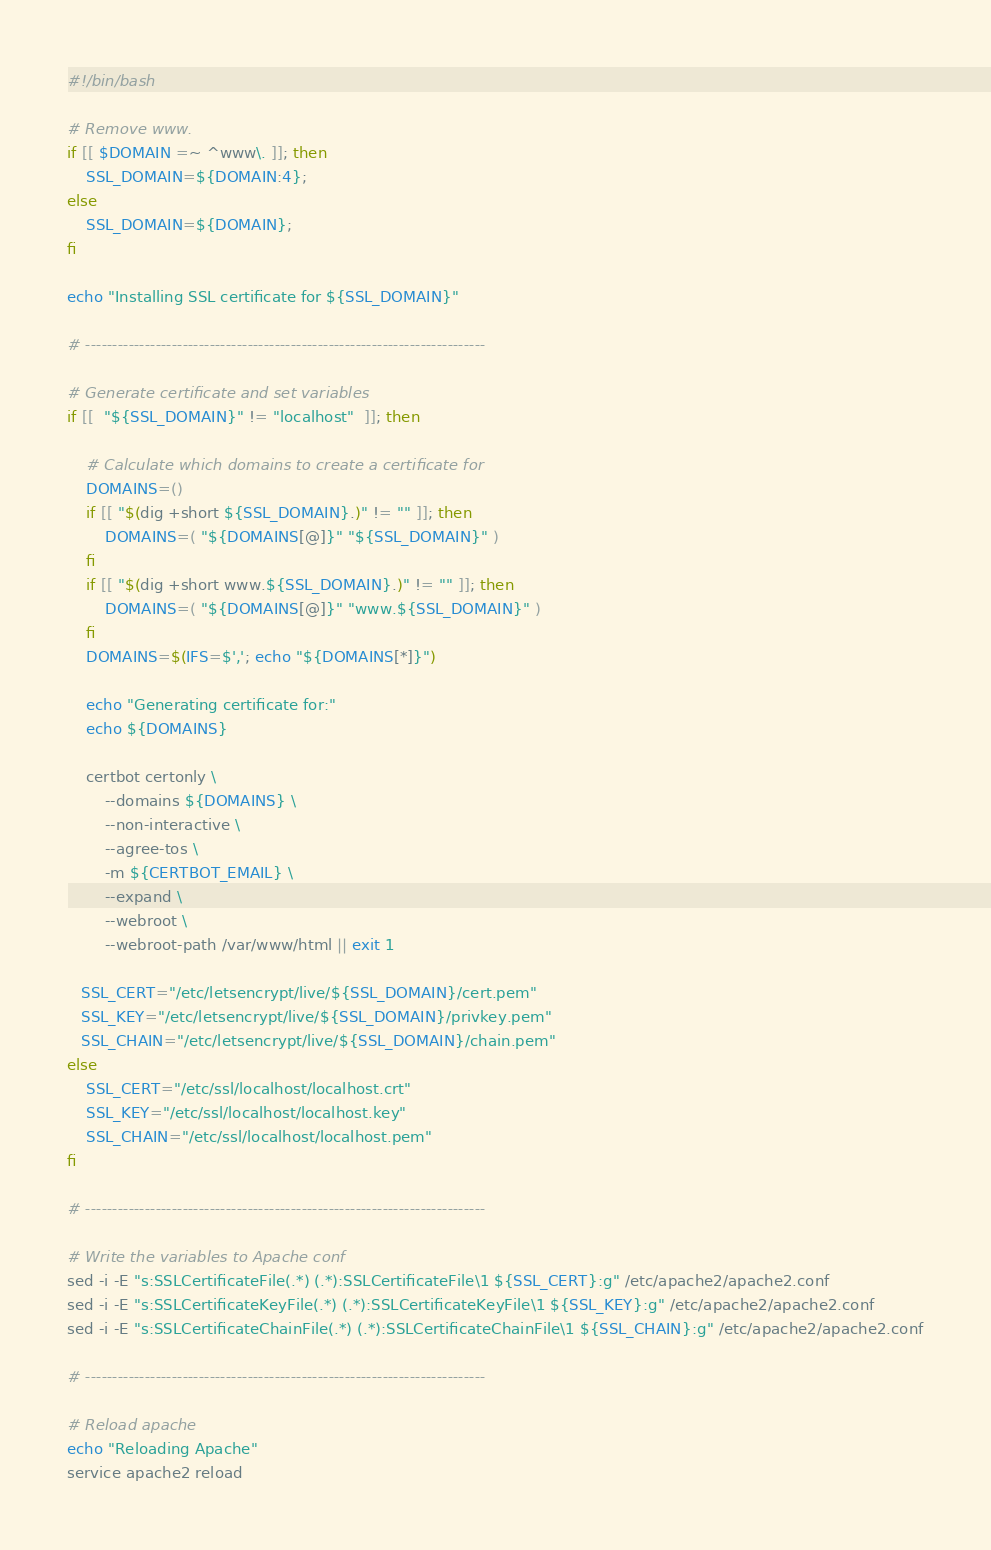Convert code to text. <code><loc_0><loc_0><loc_500><loc_500><_Bash_>#!/bin/bash

# Remove www.
if [[ $DOMAIN =~ ^www\. ]]; then
    SSL_DOMAIN=${DOMAIN:4};
else
    SSL_DOMAIN=${DOMAIN};
fi

echo "Installing SSL certificate for ${SSL_DOMAIN}"

# --------------------------------------------------------------------------

# Generate certificate and set variables
if [[  "${SSL_DOMAIN}" != "localhost"  ]]; then

    # Calculate which domains to create a certificate for
    DOMAINS=()
    if [[ "$(dig +short ${SSL_DOMAIN}.)" != "" ]]; then
        DOMAINS=( "${DOMAINS[@]}" "${SSL_DOMAIN}" )
    fi
    if [[ "$(dig +short www.${SSL_DOMAIN}.)" != "" ]]; then
        DOMAINS=( "${DOMAINS[@]}" "www.${SSL_DOMAIN}" )
    fi
    DOMAINS=$(IFS=$','; echo "${DOMAINS[*]}")

    echo "Generating certificate for:"
    echo ${DOMAINS}

    certbot certonly \
        --domains ${DOMAINS} \
        --non-interactive \
        --agree-tos \
        -m ${CERTBOT_EMAIL} \
        --expand \
        --webroot \
        --webroot-path /var/www/html || exit 1

   SSL_CERT="/etc/letsencrypt/live/${SSL_DOMAIN}/cert.pem"
   SSL_KEY="/etc/letsencrypt/live/${SSL_DOMAIN}/privkey.pem"
   SSL_CHAIN="/etc/letsencrypt/live/${SSL_DOMAIN}/chain.pem"
else
    SSL_CERT="/etc/ssl/localhost/localhost.crt"
    SSL_KEY="/etc/ssl/localhost/localhost.key"
    SSL_CHAIN="/etc/ssl/localhost/localhost.pem"
fi

# --------------------------------------------------------------------------

# Write the variables to Apache conf
sed -i -E "s:SSLCertificateFile(.*) (.*):SSLCertificateFile\1 ${SSL_CERT}:g" /etc/apache2/apache2.conf
sed -i -E "s:SSLCertificateKeyFile(.*) (.*):SSLCertificateKeyFile\1 ${SSL_KEY}:g" /etc/apache2/apache2.conf
sed -i -E "s:SSLCertificateChainFile(.*) (.*):SSLCertificateChainFile\1 ${SSL_CHAIN}:g" /etc/apache2/apache2.conf

# --------------------------------------------------------------------------

# Reload apache
echo "Reloading Apache"
service apache2 reload
</code> 